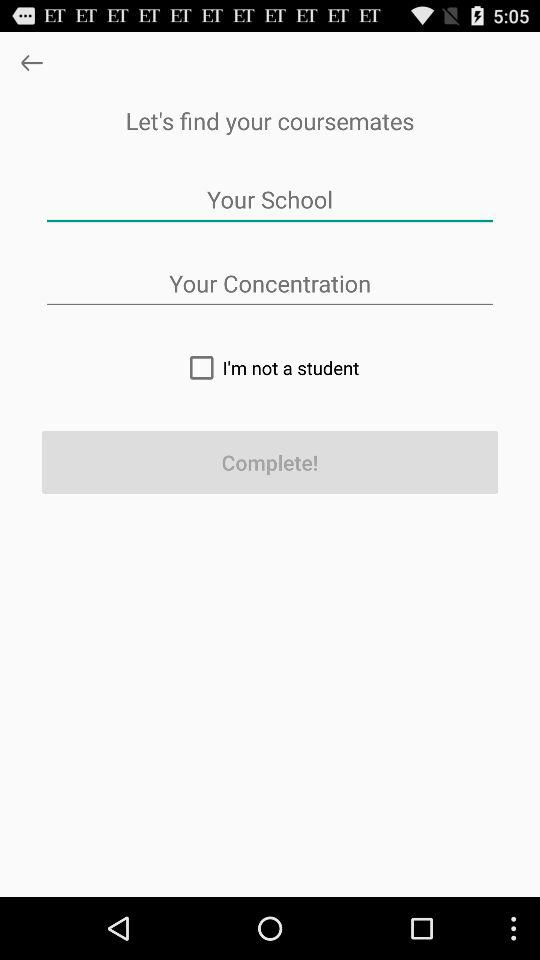Is "I'm not a student" checked or unchecked? "I'm not a student" is unchecked. 